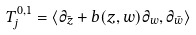<formula> <loc_0><loc_0><loc_500><loc_500>T ^ { 0 , 1 } _ { j } = \langle \partial _ { \bar { z } } + b ( z , w ) \partial _ { w } , \partial _ { \bar { w } } \rangle</formula> 